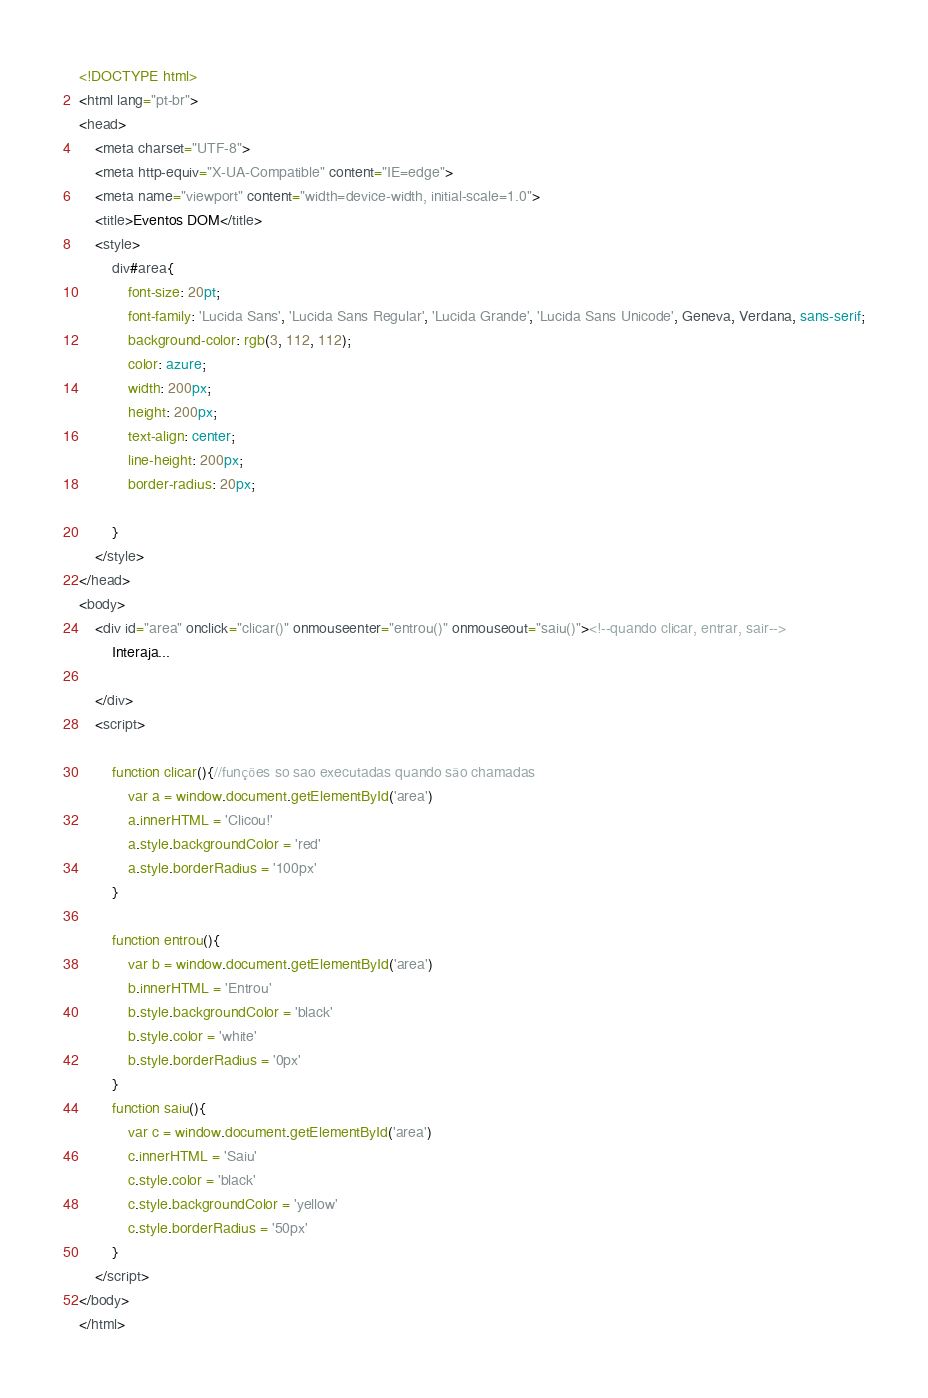Convert code to text. <code><loc_0><loc_0><loc_500><loc_500><_HTML_><!DOCTYPE html>
<html lang="pt-br">
<head>
    <meta charset="UTF-8">
    <meta http-equiv="X-UA-Compatible" content="IE=edge">
    <meta name="viewport" content="width=device-width, initial-scale=1.0">
    <title>Eventos DOM</title>
    <style>
        div#area{
            font-size: 20pt;
            font-family: 'Lucida Sans', 'Lucida Sans Regular', 'Lucida Grande', 'Lucida Sans Unicode', Geneva, Verdana, sans-serif;
            background-color: rgb(3, 112, 112);
            color: azure;
            width: 200px;
            height: 200px;
            text-align: center;
            line-height: 200px;
            border-radius: 20px;
            
        }
    </style>
</head>
<body>
    <div id="area" onclick="clicar()" onmouseenter="entrou()" onmouseout="saiu()"><!--quando clicar, entrar, sair-->
        Interaja...

    </div>
    <script>
    
        function clicar(){//funções so sao executadas quando são chamadas
            var a = window.document.getElementById('area')
            a.innerHTML = 'Clicou!'
            a.style.backgroundColor = 'red'
            a.style.borderRadius = '100px'
        }

        function entrou(){
            var b = window.document.getElementById('area')
            b.innerHTML = 'Entrou'
            b.style.backgroundColor = 'black'
            b.style.color = 'white'
            b.style.borderRadius = '0px'
        }
        function saiu(){
            var c = window.document.getElementById('area')
            c.innerHTML = 'Saiu'
            c.style.color = 'black'
            c.style.backgroundColor = 'yellow'
            c.style.borderRadius = '50px'
        }
    </script>
</body>
</html></code> 